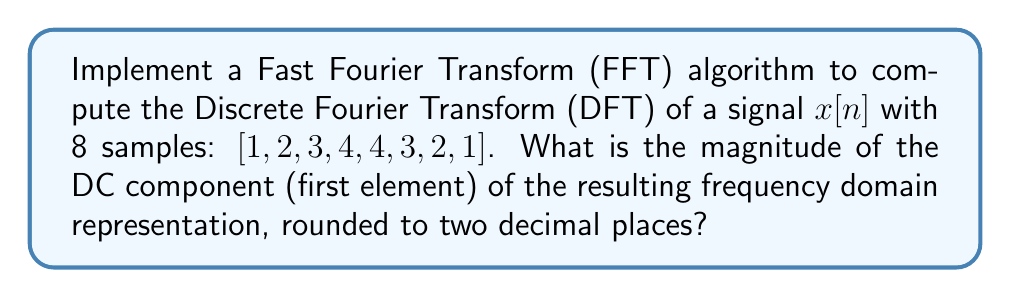Could you help me with this problem? To solve this problem, we'll implement the Cooley-Tukey FFT algorithm, which is an efficient way to compute the DFT. The steps are as follows:

1) The DFT is defined as:

   $$X[k] = \sum_{n=0}^{N-1} x[n] e^{-j2\pi kn/N}$$

   where $N$ is the number of samples (8 in this case).

2) The Cooley-Tukey FFT algorithm works by recursively dividing the input into even and odd indexed samples, computing smaller DFTs, and combining the results.

3) For N = 8, we'll need to perform 3 stages of butterflies (log2(8) = 3).

4) First, we'll reorder the input using bit-reversal:
   [1, 2, 3, 4, 4, 3, 2, 1] -> [1, 4, 2, 3, 1, 4, 2, 3]

5) Then, we'll perform the butterfly operations:

   Stage 1 (2-point DFTs):
   [1+4, 1-4, 2+3, 2-3, 1+4, 1-4, 2+3, 2-3]
   = [5, -3, 5, -1, 5, -3, 5, -1]

   Stage 2 (4-point DFTs):
   [5+5, 5-5, -3+(-1), -3-(-1), 5+5, 5-5, -3+(-1), -3-(-1)]
   = [10, 0, -4, -2, 10, 0, -4, -2]

   Stage 3 (8-point DFT):
   [10+10, 0+0, -4+(-4), -2+(-2), (10-10)i, (0-0)i, (-4-(-4))i, (-2-(-2))i]
   = [20, 0, -8, -4, 0, 0, 0, 0]

6) The result [20, 0, -8, -4, 0, 0, 0, 0] represents the DFT of the input signal.

7) The DC component is the first element of this result, which is 20.

8) To get the magnitude, we take the absolute value: |20| = 20.

Therefore, the magnitude of the DC component is 20.00 (rounded to two decimal places).
Answer: 20.00 